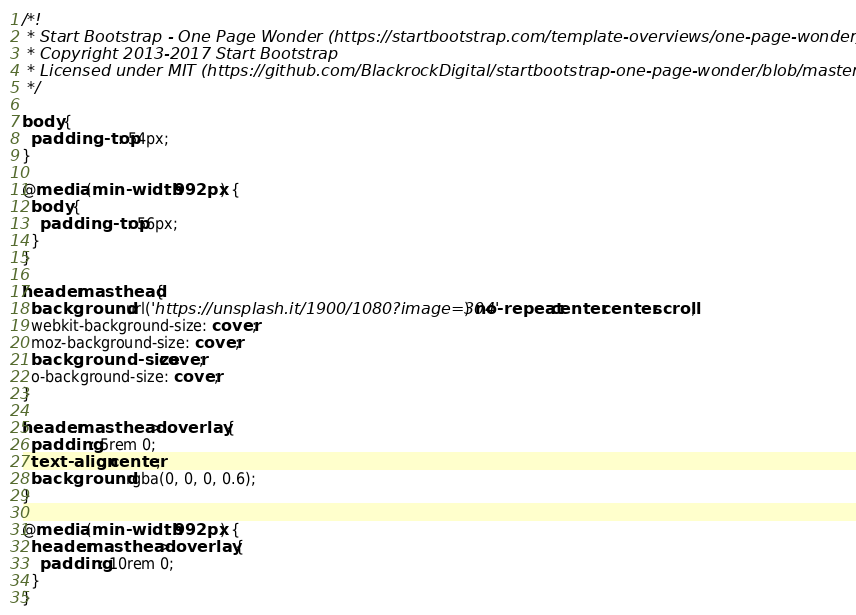<code> <loc_0><loc_0><loc_500><loc_500><_CSS_>/*!
 * Start Bootstrap - One Page Wonder (https://startbootstrap.com/template-overviews/one-page-wonder)
 * Copyright 2013-2017 Start Bootstrap
 * Licensed under MIT (https://github.com/BlackrockDigital/startbootstrap-one-page-wonder/blob/master/LICENSE)
 */

body {
  padding-top: 54px;
}

@media (min-width: 992px) {
  body {
    padding-top: 56px;
  }
}

header.masthead {
  background: url('https://unsplash.it/1900/1080?image=304') no-repeat center center scroll;
  webkit-background-size: cover;
  moz-background-size: cover;
  background-size: cover;
  o-background-size: cover;
}

header.masthead>.overlay {
  padding: 5rem 0;
  text-align: center;
  background: rgba(0, 0, 0, 0.6);
}

@media (min-width: 992px) {
  header.masthead>.overlay {
    padding: 10rem 0;
  }
}
</code> 